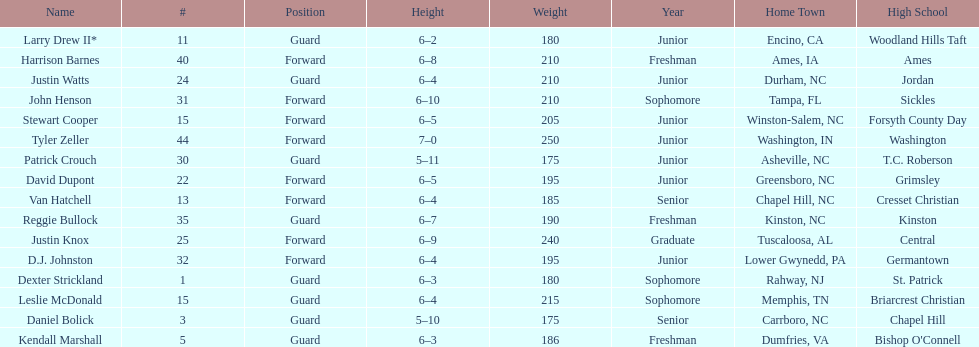Who was taller, justin knox or john henson? John Henson. 